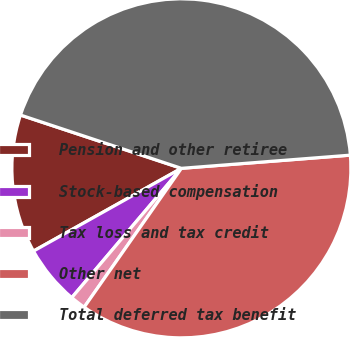<chart> <loc_0><loc_0><loc_500><loc_500><pie_chart><fcel>Pension and other retiree<fcel>Stock-based compensation<fcel>Tax loss and tax credit<fcel>Other net<fcel>Total deferred tax benefit<nl><fcel>13.21%<fcel>5.69%<fcel>1.47%<fcel>35.96%<fcel>43.67%<nl></chart> 